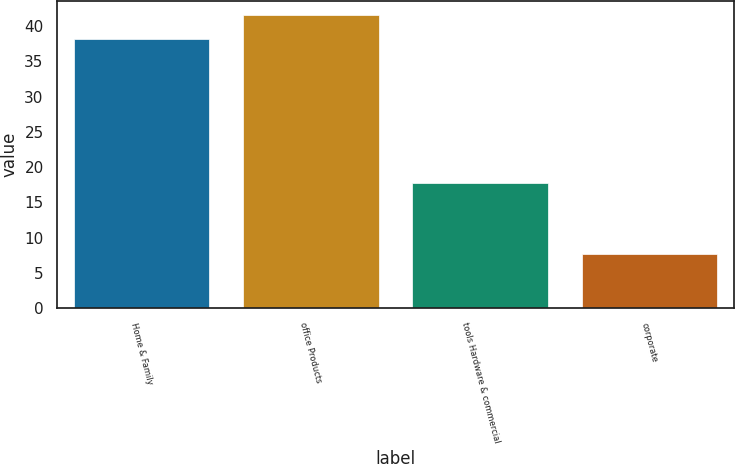Convert chart to OTSL. <chart><loc_0><loc_0><loc_500><loc_500><bar_chart><fcel>Home & Family<fcel>office Products<fcel>tools Hardware & commercial<fcel>corporate<nl><fcel>38.2<fcel>41.55<fcel>17.8<fcel>7.7<nl></chart> 